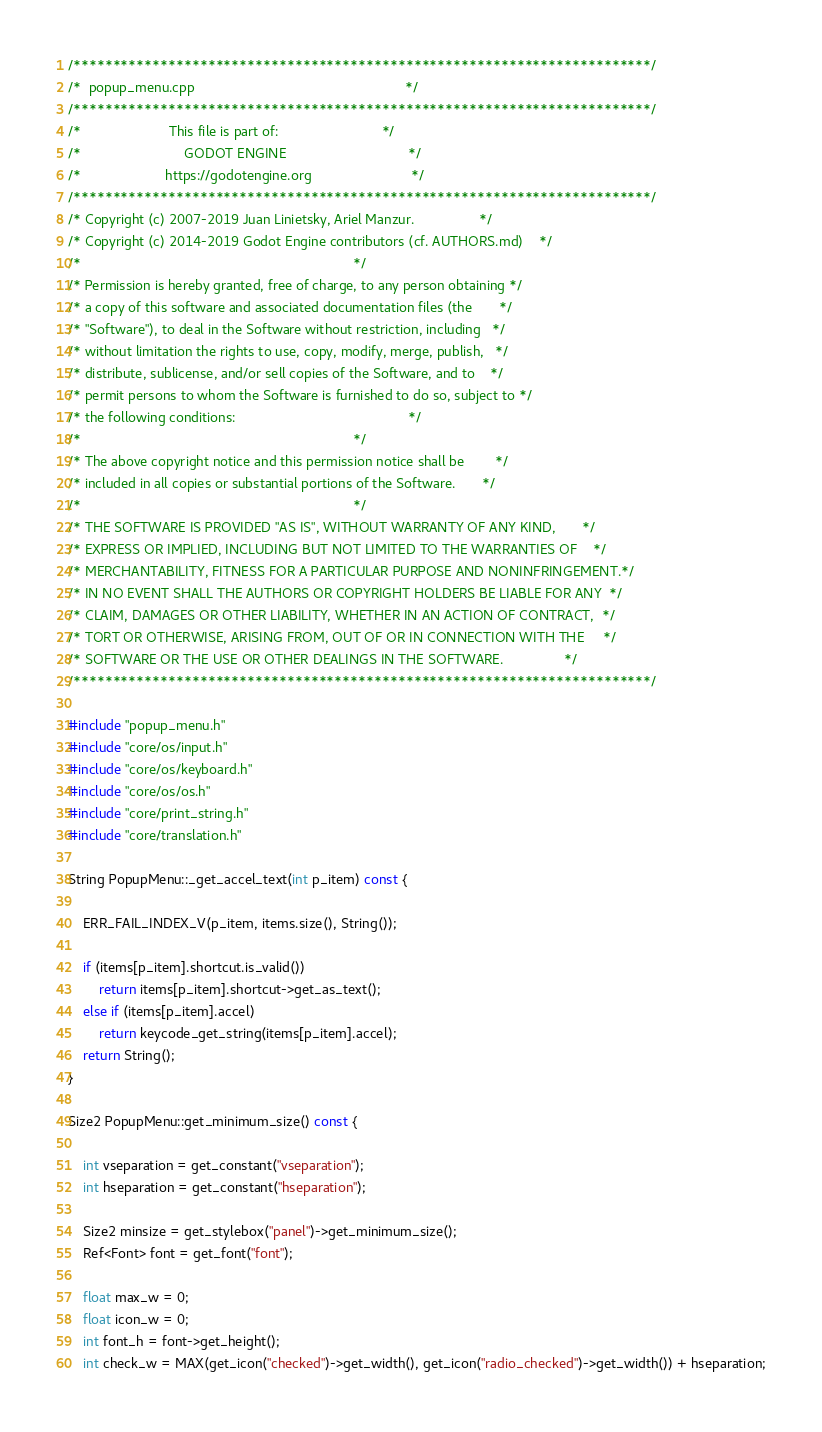Convert code to text. <code><loc_0><loc_0><loc_500><loc_500><_C++_>/*************************************************************************/
/*  popup_menu.cpp                                                       */
/*************************************************************************/
/*                       This file is part of:                           */
/*                           GODOT ENGINE                                */
/*                      https://godotengine.org                          */
/*************************************************************************/
/* Copyright (c) 2007-2019 Juan Linietsky, Ariel Manzur.                 */
/* Copyright (c) 2014-2019 Godot Engine contributors (cf. AUTHORS.md)    */
/*                                                                       */
/* Permission is hereby granted, free of charge, to any person obtaining */
/* a copy of this software and associated documentation files (the       */
/* "Software"), to deal in the Software without restriction, including   */
/* without limitation the rights to use, copy, modify, merge, publish,   */
/* distribute, sublicense, and/or sell copies of the Software, and to    */
/* permit persons to whom the Software is furnished to do so, subject to */
/* the following conditions:                                             */
/*                                                                       */
/* The above copyright notice and this permission notice shall be        */
/* included in all copies or substantial portions of the Software.       */
/*                                                                       */
/* THE SOFTWARE IS PROVIDED "AS IS", WITHOUT WARRANTY OF ANY KIND,       */
/* EXPRESS OR IMPLIED, INCLUDING BUT NOT LIMITED TO THE WARRANTIES OF    */
/* MERCHANTABILITY, FITNESS FOR A PARTICULAR PURPOSE AND NONINFRINGEMENT.*/
/* IN NO EVENT SHALL THE AUTHORS OR COPYRIGHT HOLDERS BE LIABLE FOR ANY  */
/* CLAIM, DAMAGES OR OTHER LIABILITY, WHETHER IN AN ACTION OF CONTRACT,  */
/* TORT OR OTHERWISE, ARISING FROM, OUT OF OR IN CONNECTION WITH THE     */
/* SOFTWARE OR THE USE OR OTHER DEALINGS IN THE SOFTWARE.                */
/*************************************************************************/

#include "popup_menu.h"
#include "core/os/input.h"
#include "core/os/keyboard.h"
#include "core/os/os.h"
#include "core/print_string.h"
#include "core/translation.h"

String PopupMenu::_get_accel_text(int p_item) const {

	ERR_FAIL_INDEX_V(p_item, items.size(), String());

	if (items[p_item].shortcut.is_valid())
		return items[p_item].shortcut->get_as_text();
	else if (items[p_item].accel)
		return keycode_get_string(items[p_item].accel);
	return String();
}

Size2 PopupMenu::get_minimum_size() const {

	int vseparation = get_constant("vseparation");
	int hseparation = get_constant("hseparation");

	Size2 minsize = get_stylebox("panel")->get_minimum_size();
	Ref<Font> font = get_font("font");

	float max_w = 0;
	float icon_w = 0;
	int font_h = font->get_height();
	int check_w = MAX(get_icon("checked")->get_width(), get_icon("radio_checked")->get_width()) + hseparation;</code> 